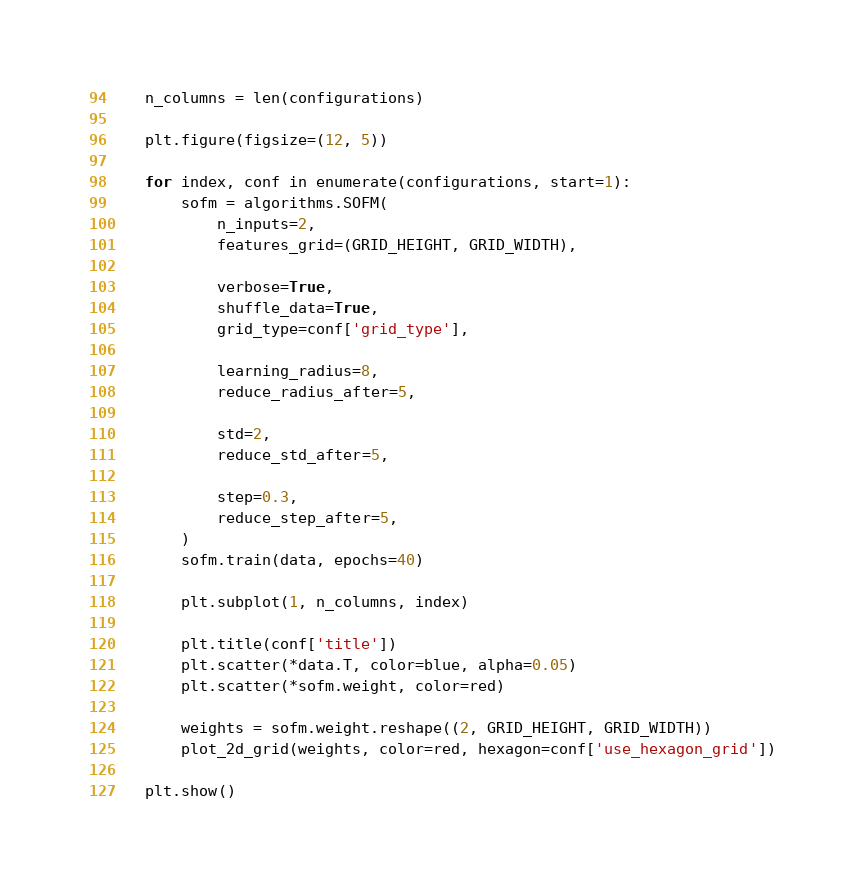Convert code to text. <code><loc_0><loc_0><loc_500><loc_500><_Python_>    n_columns = len(configurations)

    plt.figure(figsize=(12, 5))

    for index, conf in enumerate(configurations, start=1):
        sofm = algorithms.SOFM(
            n_inputs=2,
            features_grid=(GRID_HEIGHT, GRID_WIDTH),

            verbose=True,
            shuffle_data=True,
            grid_type=conf['grid_type'],

            learning_radius=8,
            reduce_radius_after=5,

            std=2,
            reduce_std_after=5,

            step=0.3,
            reduce_step_after=5,
        )
        sofm.train(data, epochs=40)

        plt.subplot(1, n_columns, index)

        plt.title(conf['title'])
        plt.scatter(*data.T, color=blue, alpha=0.05)
        plt.scatter(*sofm.weight, color=red)

        weights = sofm.weight.reshape((2, GRID_HEIGHT, GRID_WIDTH))
        plot_2d_grid(weights, color=red, hexagon=conf['use_hexagon_grid'])

    plt.show()
</code> 